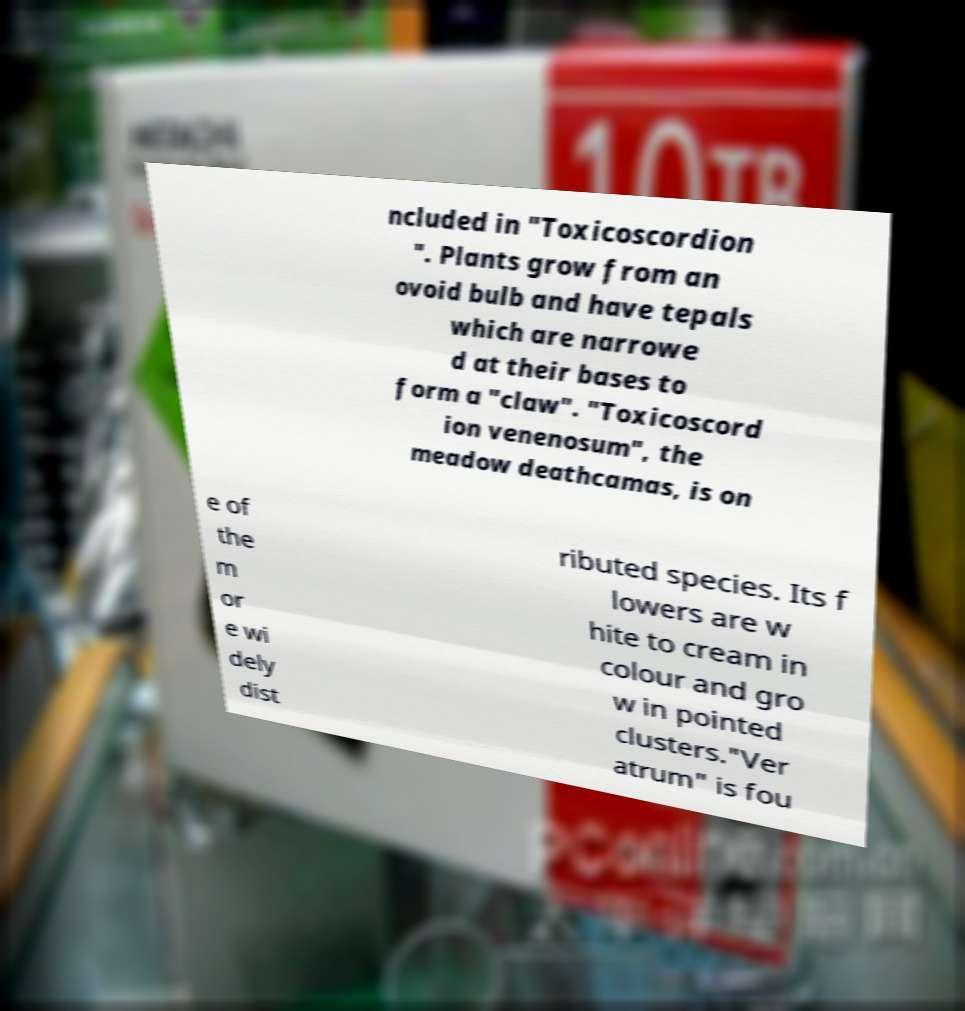Can you accurately transcribe the text from the provided image for me? ncluded in "Toxicoscordion ". Plants grow from an ovoid bulb and have tepals which are narrowe d at their bases to form a "claw". "Toxicoscord ion venenosum", the meadow deathcamas, is on e of the m or e wi dely dist ributed species. Its f lowers are w hite to cream in colour and gro w in pointed clusters."Ver atrum" is fou 